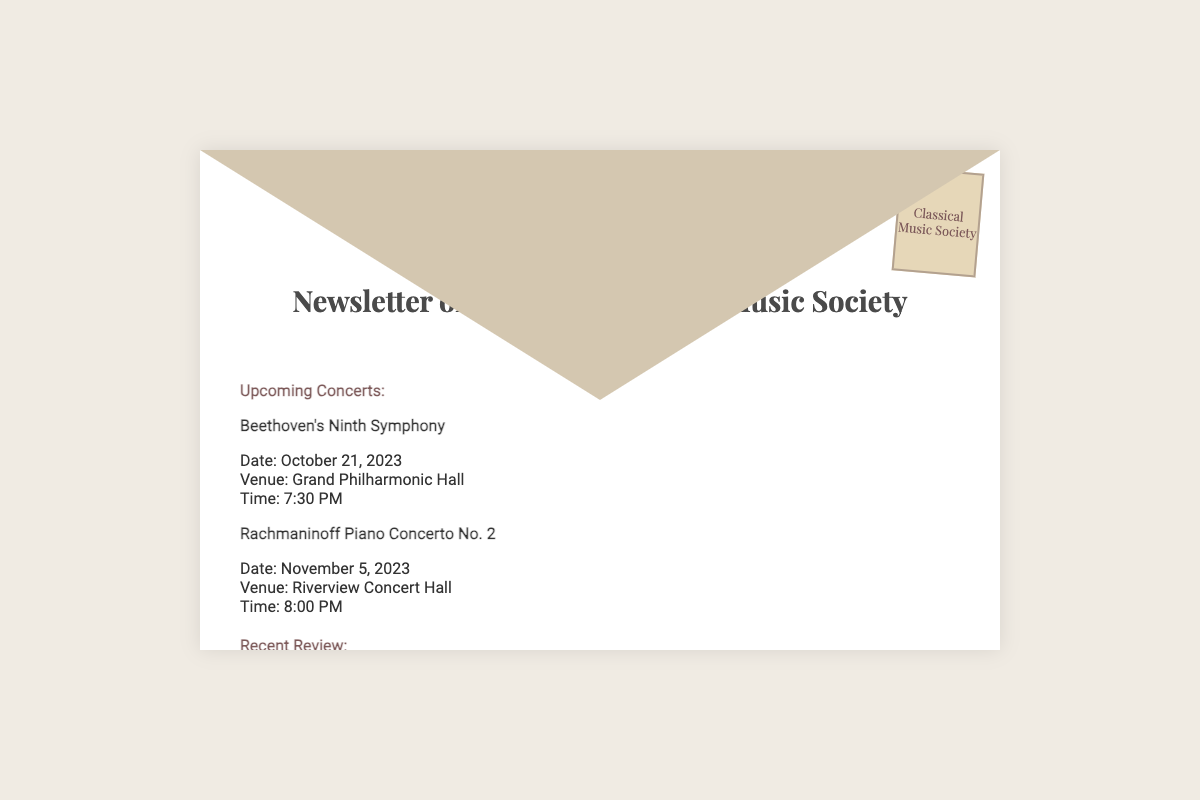What is the title of the newsletter? The title of the newsletter is prominently displayed at the top of the document.
Answer: The Harmony Herald What is the date of the Beethoven concert? The date of the Beethoven concert can be found in the upcoming concerts section.
Answer: October 21, 2023 Where is the Rachmaninoff concert being held? The venue for the Rachmaninoff concert is specified in the document.
Answer: Riverview Concert Hall Who is the featured artist in the interview? The document specifies the musician who was interviewed.
Answer: Yo-Yo Ma What was the recent concert reviewed? The review section mentions the concert that took place last Saturday.
Answer: A Night with the Masters What is the time for the Beethoven concert? The document states the time for the Beethoven concert in the upcoming events section.
Answer: 7:30 PM How many upcoming concerts are listed? The number of events in the upcoming concerts section indicates how many concerts are featured.
Answer: Two What is the venue for the concert on November 5, 2023? The venue for the second concert is clearly stated in the document.
Answer: Riverview Concert Hall What phrase encourages readers at the end of the document? The concluding statement offers inspiration related to music.
Answer: Let the music inspire and elevate your spirit! 